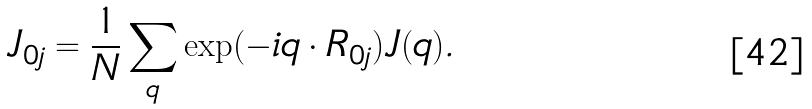<formula> <loc_0><loc_0><loc_500><loc_500>J _ { 0 j } = \frac { 1 } { N } \sum _ { q } \exp ( - i { q \cdot R _ { 0 j } } ) J ( { q } ) .</formula> 